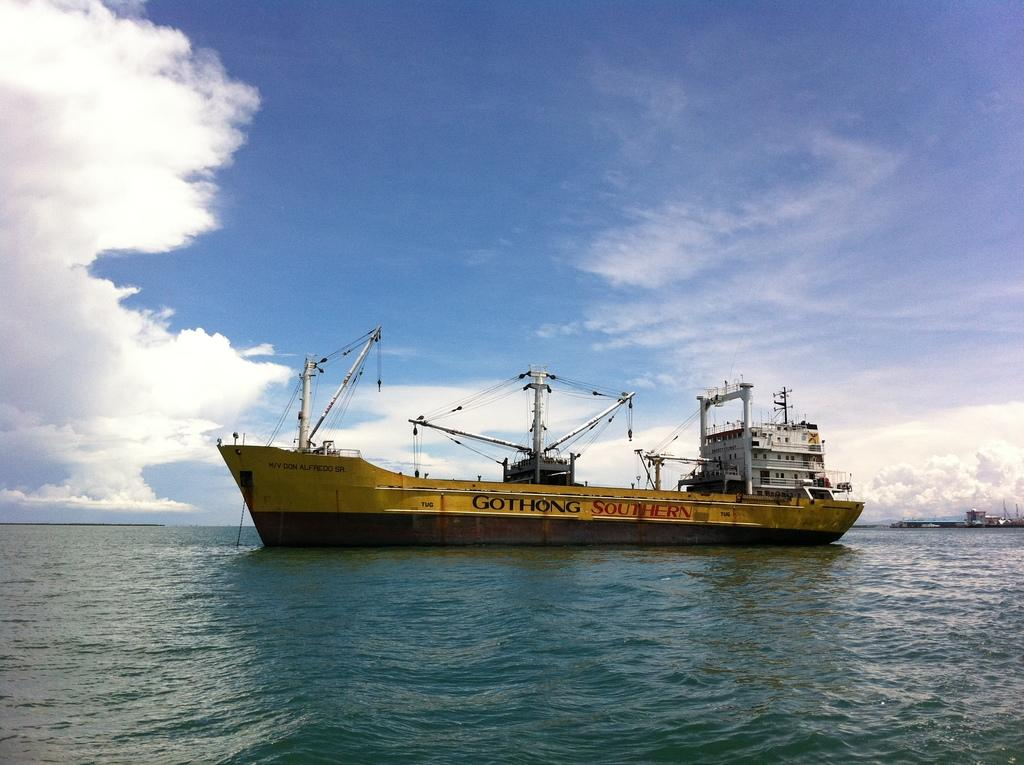What is the main subject of the image? The main subject of the image is a ship. Where is the ship located? The ship is on the water. What else can be seen in the image besides the ship? There are objects in the image. What is visible in the background of the image? The sky is visible in the background of the image. What can be observed in the sky? Clouds are present in the sky. How many spiders are crawling on the ship in the image? There are no spiders present in the image. Is there a farmer working on the ship in the image? There is no farmer present in the image. 